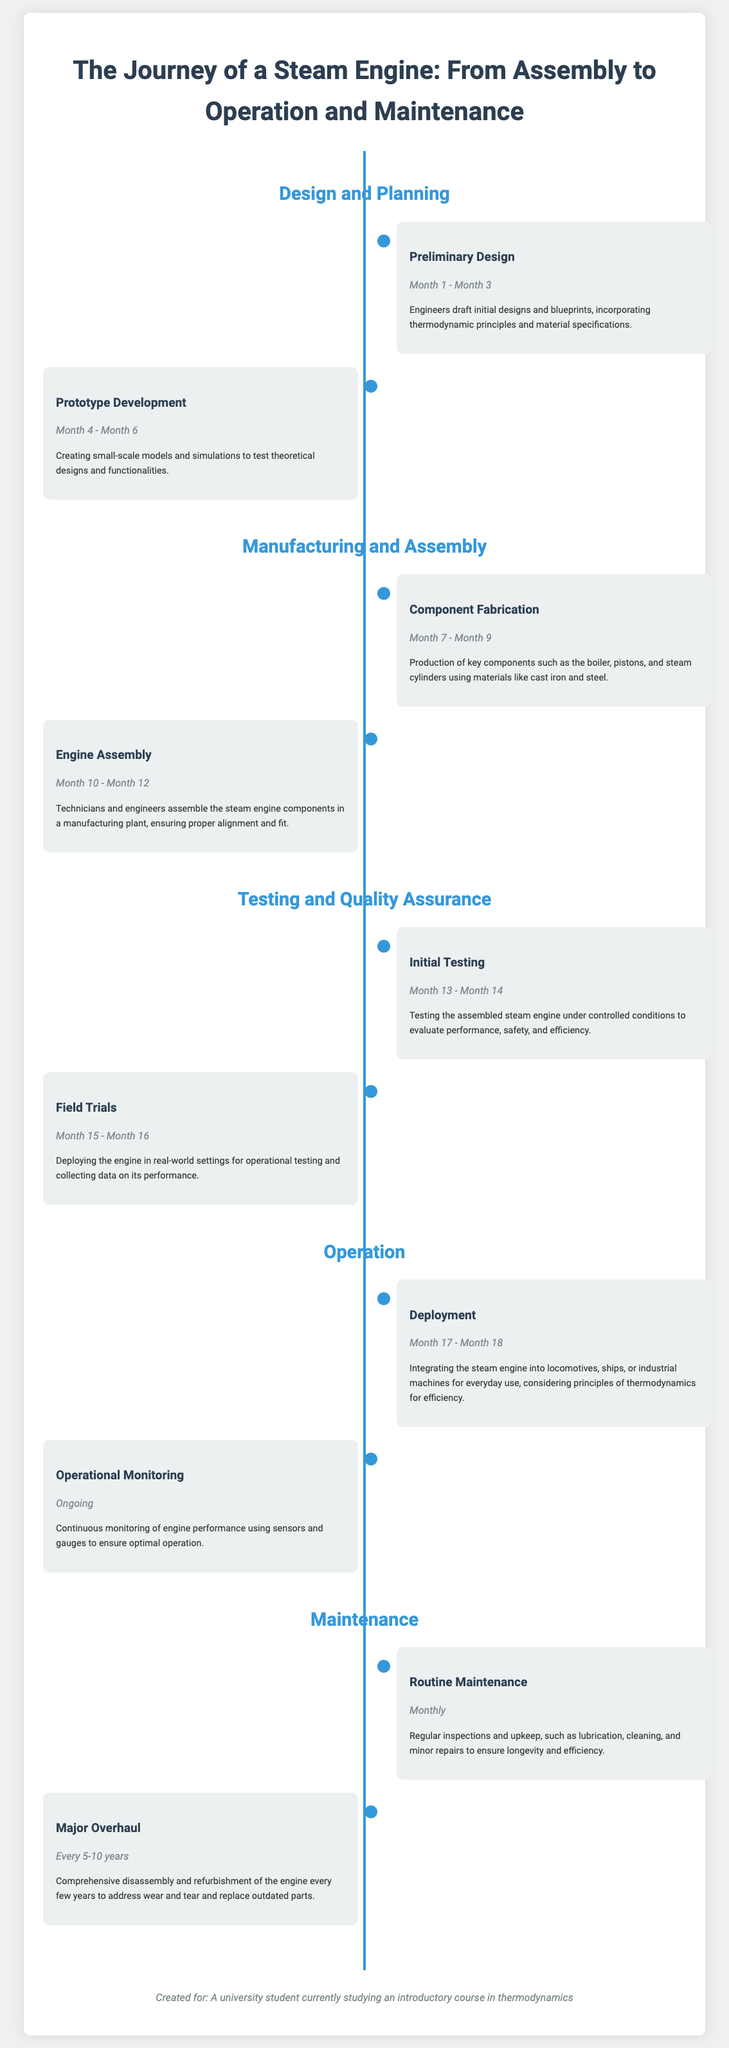What is the title of the document? The title of the document is stated prominently at the top of the timeline infographic.
Answer: The Journey of a Steam Engine: From Assembly to Operation and Maintenance What is the first phase in the timeline? The first phase in the timeline is the initial section focused on the development process of the steam engine.
Answer: Design and Planning How long does the Prototype Development last? The duration for Prototype Development is specified in the document within the relevant event's date range.
Answer: Month 4 - Month 6 What key components are mentioned in the Component Fabrication event? The document lists what components are fabricated during this phase, showing the focus on material production.
Answer: Boiler, pistons, and steam cylinders When does Operational Monitoring begin? The timeline specifies that Operational Monitoring is an ongoing process with no defined start date.
Answer: Ongoing What is the frequency of Routine Maintenance? The maintenance routine is mentioned with specific timing for regular checks and servicing.
Answer: Monthly What is the duration between Major Overhauls? The timeline infers the interval at which major maintenance is required, ensuring engine reliability.
Answer: Every 5-10 years What type of testing is conducted first after assembly? The sequence of events outlines the type of testing that takes place immediately following the assembly phase.
Answer: Initial Testing What type of document is this infographic? The formatting and organization suggest the nature of the document and its intended purpose.
Answer: Timeline infographic 